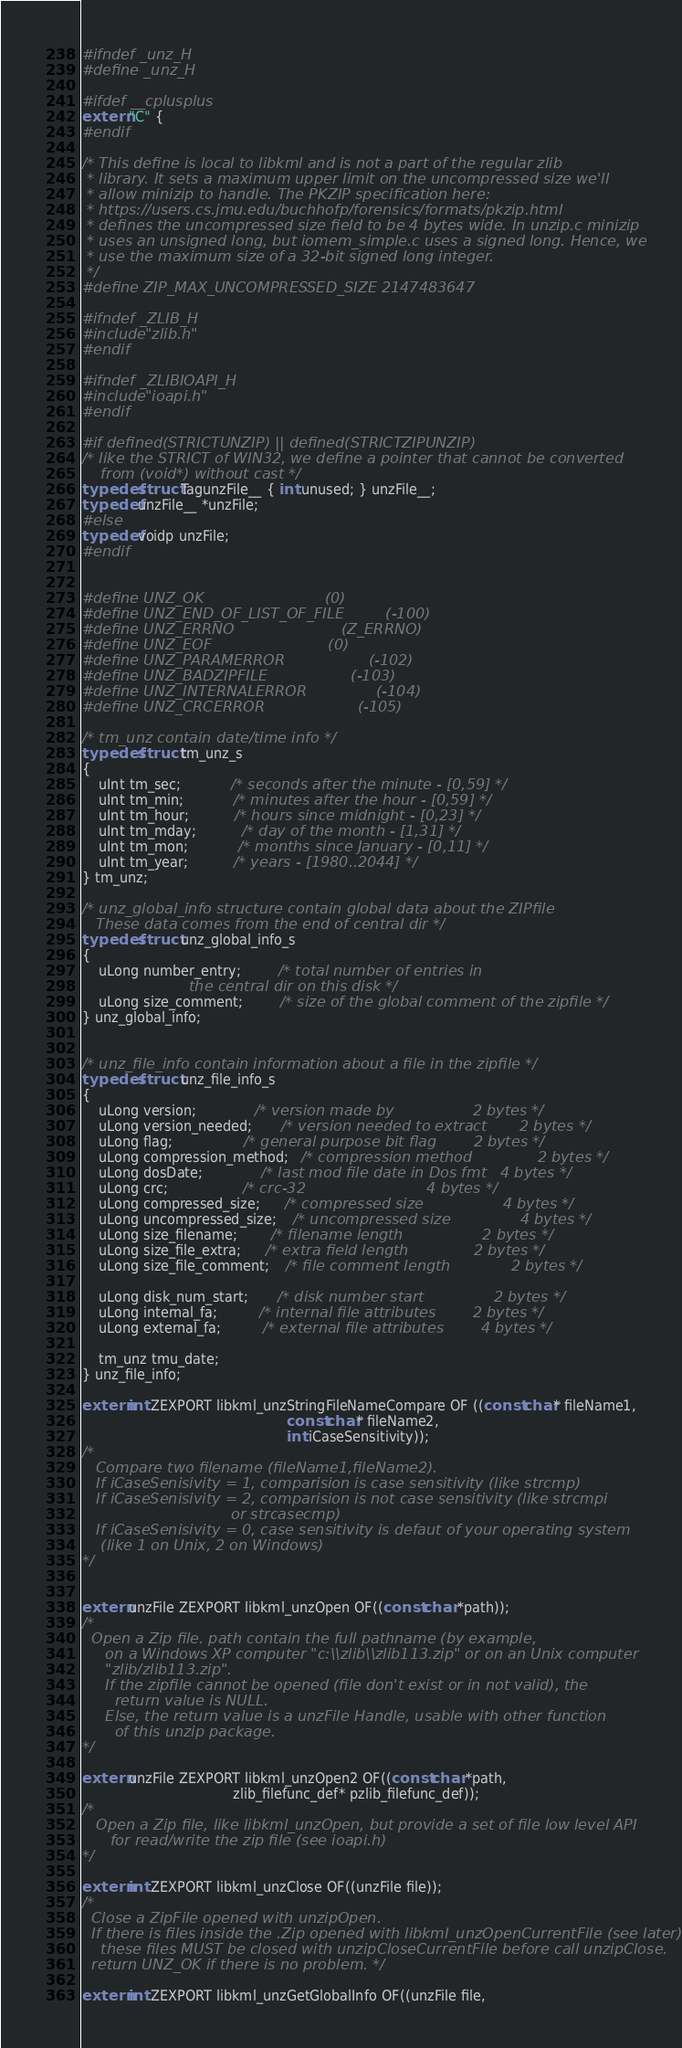Convert code to text. <code><loc_0><loc_0><loc_500><loc_500><_C_>
#ifndef _unz_H
#define _unz_H

#ifdef __cplusplus
extern "C" {
#endif

/* This define is local to libkml and is not a part of the regular zlib
 * library. It sets a maximum upper limit on the uncompressed size we'll
 * allow minizip to handle. The PKZIP specification here:
 * https://users.cs.jmu.edu/buchhofp/forensics/formats/pkzip.html
 * defines the uncompressed size field to be 4 bytes wide. In unzip.c minizip
 * uses an unsigned long, but iomem_simple.c uses a signed long. Hence, we
 * use the maximum size of a 32-bit signed long integer.
 */
#define ZIP_MAX_UNCOMPRESSED_SIZE 2147483647

#ifndef _ZLIB_H
#include "zlib.h"
#endif

#ifndef _ZLIBIOAPI_H
#include "ioapi.h"
#endif

#if defined(STRICTUNZIP) || defined(STRICTZIPUNZIP)
/* like the STRICT of WIN32, we define a pointer that cannot be converted
    from (void*) without cast */
typedef struct TagunzFile__ { int unused; } unzFile__;
typedef unzFile__ *unzFile;
#else
typedef voidp unzFile;
#endif


#define UNZ_OK                          (0)
#define UNZ_END_OF_LIST_OF_FILE         (-100)
#define UNZ_ERRNO                       (Z_ERRNO)
#define UNZ_EOF                         (0)
#define UNZ_PARAMERROR                  (-102)
#define UNZ_BADZIPFILE                  (-103)
#define UNZ_INTERNALERROR               (-104)
#define UNZ_CRCERROR                    (-105)

/* tm_unz contain date/time info */
typedef struct tm_unz_s
{
    uInt tm_sec;            /* seconds after the minute - [0,59] */
    uInt tm_min;            /* minutes after the hour - [0,59] */
    uInt tm_hour;           /* hours since midnight - [0,23] */
    uInt tm_mday;           /* day of the month - [1,31] */
    uInt tm_mon;            /* months since January - [0,11] */
    uInt tm_year;           /* years - [1980..2044] */
} tm_unz;

/* unz_global_info structure contain global data about the ZIPfile
   These data comes from the end of central dir */
typedef struct unz_global_info_s
{
    uLong number_entry;         /* total number of entries in
                       the central dir on this disk */
    uLong size_comment;         /* size of the global comment of the zipfile */
} unz_global_info;


/* unz_file_info contain information about a file in the zipfile */
typedef struct unz_file_info_s
{
    uLong version;              /* version made by                 2 bytes */
    uLong version_needed;       /* version needed to extract       2 bytes */
    uLong flag;                 /* general purpose bit flag        2 bytes */
    uLong compression_method;   /* compression method              2 bytes */
    uLong dosDate;              /* last mod file date in Dos fmt   4 bytes */
    uLong crc;                  /* crc-32                          4 bytes */
    uLong compressed_size;      /* compressed size                 4 bytes */
    uLong uncompressed_size;    /* uncompressed size               4 bytes */
    uLong size_filename;        /* filename length                 2 bytes */
    uLong size_file_extra;      /* extra field length              2 bytes */
    uLong size_file_comment;    /* file comment length             2 bytes */

    uLong disk_num_start;       /* disk number start               2 bytes */
    uLong internal_fa;          /* internal file attributes        2 bytes */
    uLong external_fa;          /* external file attributes        4 bytes */

    tm_unz tmu_date;
} unz_file_info;

extern int ZEXPORT libkml_unzStringFileNameCompare OF ((const char* fileName1,
                                                 const char* fileName2,
                                                 int iCaseSensitivity));
/*
   Compare two filename (fileName1,fileName2).
   If iCaseSenisivity = 1, comparision is case sensitivity (like strcmp)
   If iCaseSenisivity = 2, comparision is not case sensitivity (like strcmpi
                                or strcasecmp)
   If iCaseSenisivity = 0, case sensitivity is defaut of your operating system
    (like 1 on Unix, 2 on Windows)
*/


extern unzFile ZEXPORT libkml_unzOpen OF((const char *path));
/*
  Open a Zip file. path contain the full pathname (by example,
     on a Windows XP computer "c:\\zlib\\zlib113.zip" or on an Unix computer
     "zlib/zlib113.zip".
     If the zipfile cannot be opened (file don't exist or in not valid), the
       return value is NULL.
     Else, the return value is a unzFile Handle, usable with other function
       of this unzip package.
*/

extern unzFile ZEXPORT libkml_unzOpen2 OF((const char *path,
                                    zlib_filefunc_def* pzlib_filefunc_def));
/*
   Open a Zip file, like libkml_unzOpen, but provide a set of file low level API
      for read/write the zip file (see ioapi.h)
*/

extern int ZEXPORT libkml_unzClose OF((unzFile file));
/*
  Close a ZipFile opened with unzipOpen.
  If there is files inside the .Zip opened with libkml_unzOpenCurrentFile (see later),
    these files MUST be closed with unzipCloseCurrentFile before call unzipClose.
  return UNZ_OK if there is no problem. */

extern int ZEXPORT libkml_unzGetGlobalInfo OF((unzFile file,</code> 